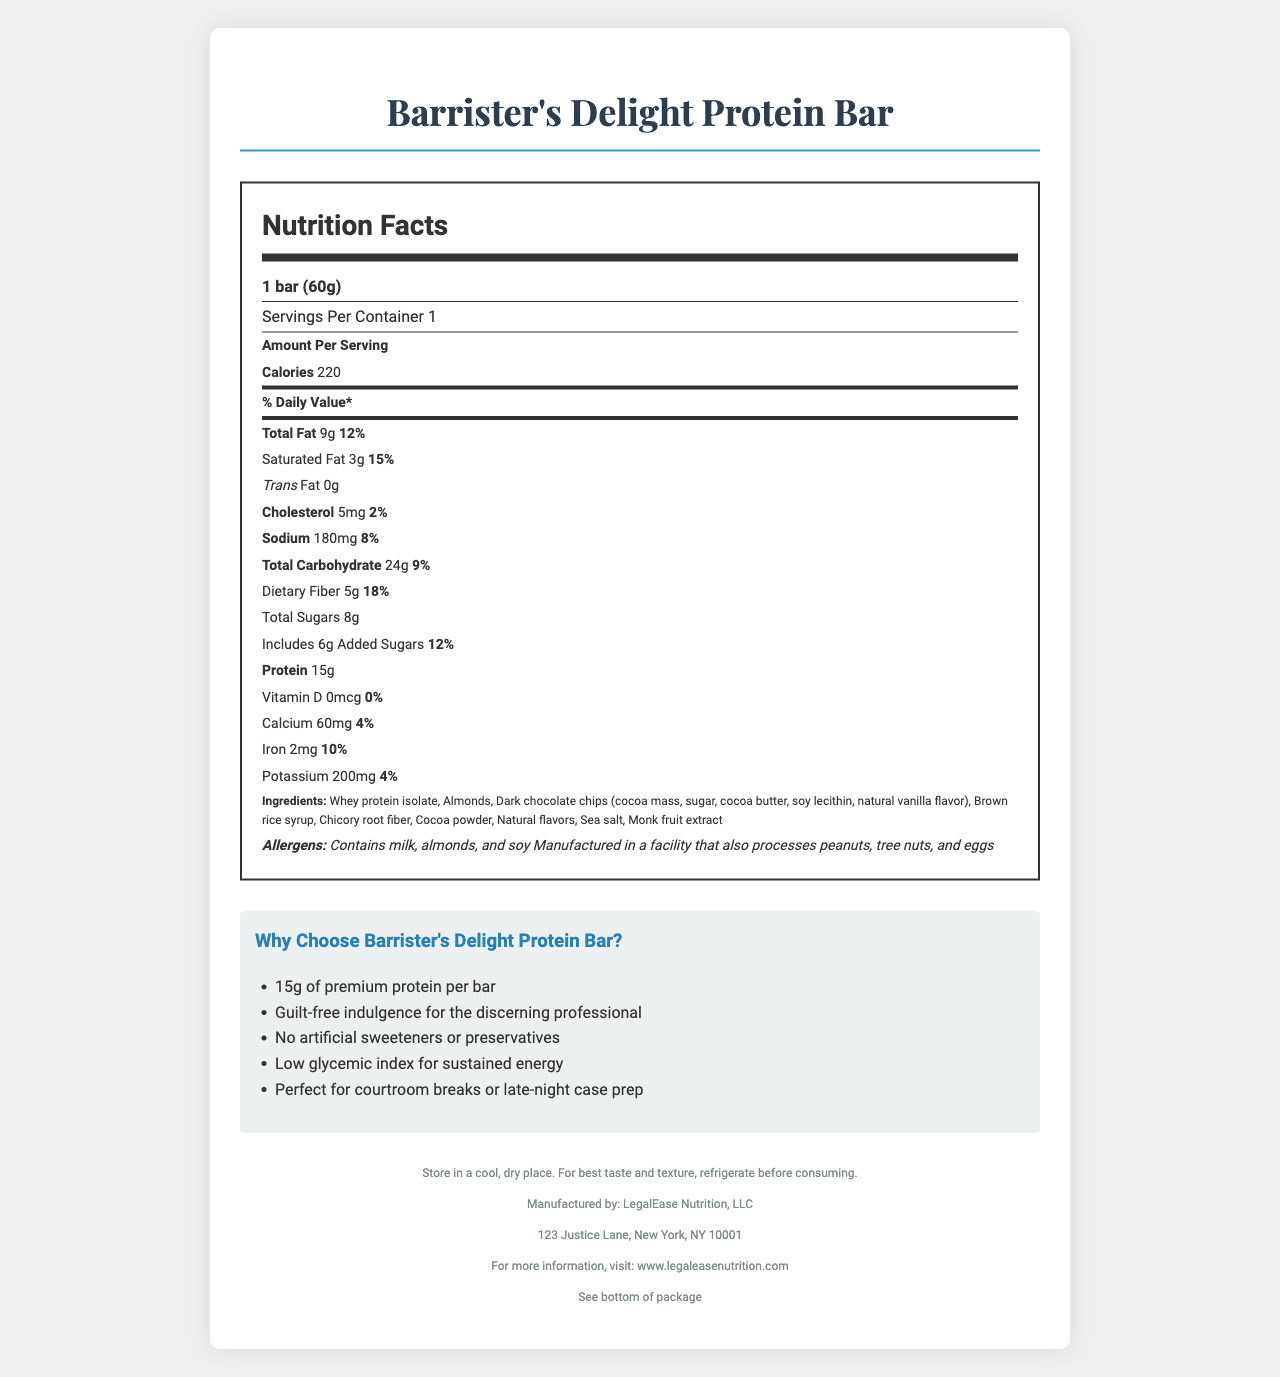What is the serving size of Barrister's Delight Protein Bar? The serving size is explicitly stated at the beginning of the nutrition label.
Answer: 1 bar (60g) How many calories are in one serving? The number of calories per serving is listed prominently under the "Amount Per Serving" section.
Answer: 220 How much protein does one bar contain? The amount of protein is clearly indicated in the nutrition facts.
Answer: 15g How much calcium is in the bar and what percentage of the daily value does it represent? The amount of calcium and its corresponding daily value percentage are both specified in the vitamin and mineral section of the nutrition label.
Answer: 60mg, 4% What allergens are present in this protein bar? The allergen information is stated in the allergens section at the bottom of the nutrition facts.
Answer: Milk, almonds, and soy Which of the following is not an ingredient in the Barrister's Delight Protein Bar? A. Brown rice syrup B. Chicory root fiber C. High fructose corn syrup D. Monk fruit extract The list of ingredients includes Brown rice syrup, Chicory root fiber, and Monk fruit extract but not High fructose corn syrup.
Answer: C. High fructose corn syrup What is the daily value percentage for saturated fat in this protein bar? The daily value percentage for saturated fat is listed right after its amount under the total fat section.
Answer: 15% What is the marketing claim about artificial sweeteners or preservatives? A. Contains artificial sweeteners B. No artificial sweeteners or preservatives C. Contains preservatives D. Only natural sweeteners The marketing claims section states that the bar has no artificial sweeteners or preservatives.
Answer: B. No artificial sweeteners or preservatives Does this bar contain any trans fat? The label explicitly states that the bar contains 0g of trans fat.
Answer: No Summarize the main idea of the document. The document presents various details about the Barrister's Delight Protein Bar, including its nutritional content, ingredients, allergen warnings, claims about its benefits, and storage instructions, emphasizing its suitability for professionals who need a nutritious and convenient snack.
Answer: The document provides detailed nutritional information, ingredients, allergens, marketing claims, and storage instructions for Barrister's Delight Protein Bar, positioning it as a healthy and convenient snack option for professionals. How many grams of added sugars are there in a serving? The amount of added sugars is listed under the total carbohydrate section.
Answer: 6g Is this protein bar suitable for someone who is allergic to peanuts? Although the bar itself does not list peanuts as an ingredient, it is manufactured in a facility that also processes peanuts, which could pose a risk for someone with a peanut allergy.
Answer: Cannot be determined What company manufactures Barrister's Delight Protein Bar? The manufacturer is mentioned at the bottom of the document in the footer section.
Answer: LegalEase Nutrition, LLC 